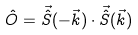Convert formula to latex. <formula><loc_0><loc_0><loc_500><loc_500>\hat { O } = { \vec { \hat { S } } } ( - \vec { k } ) \cdot \vec { \hat { S } } ( \vec { k } )</formula> 